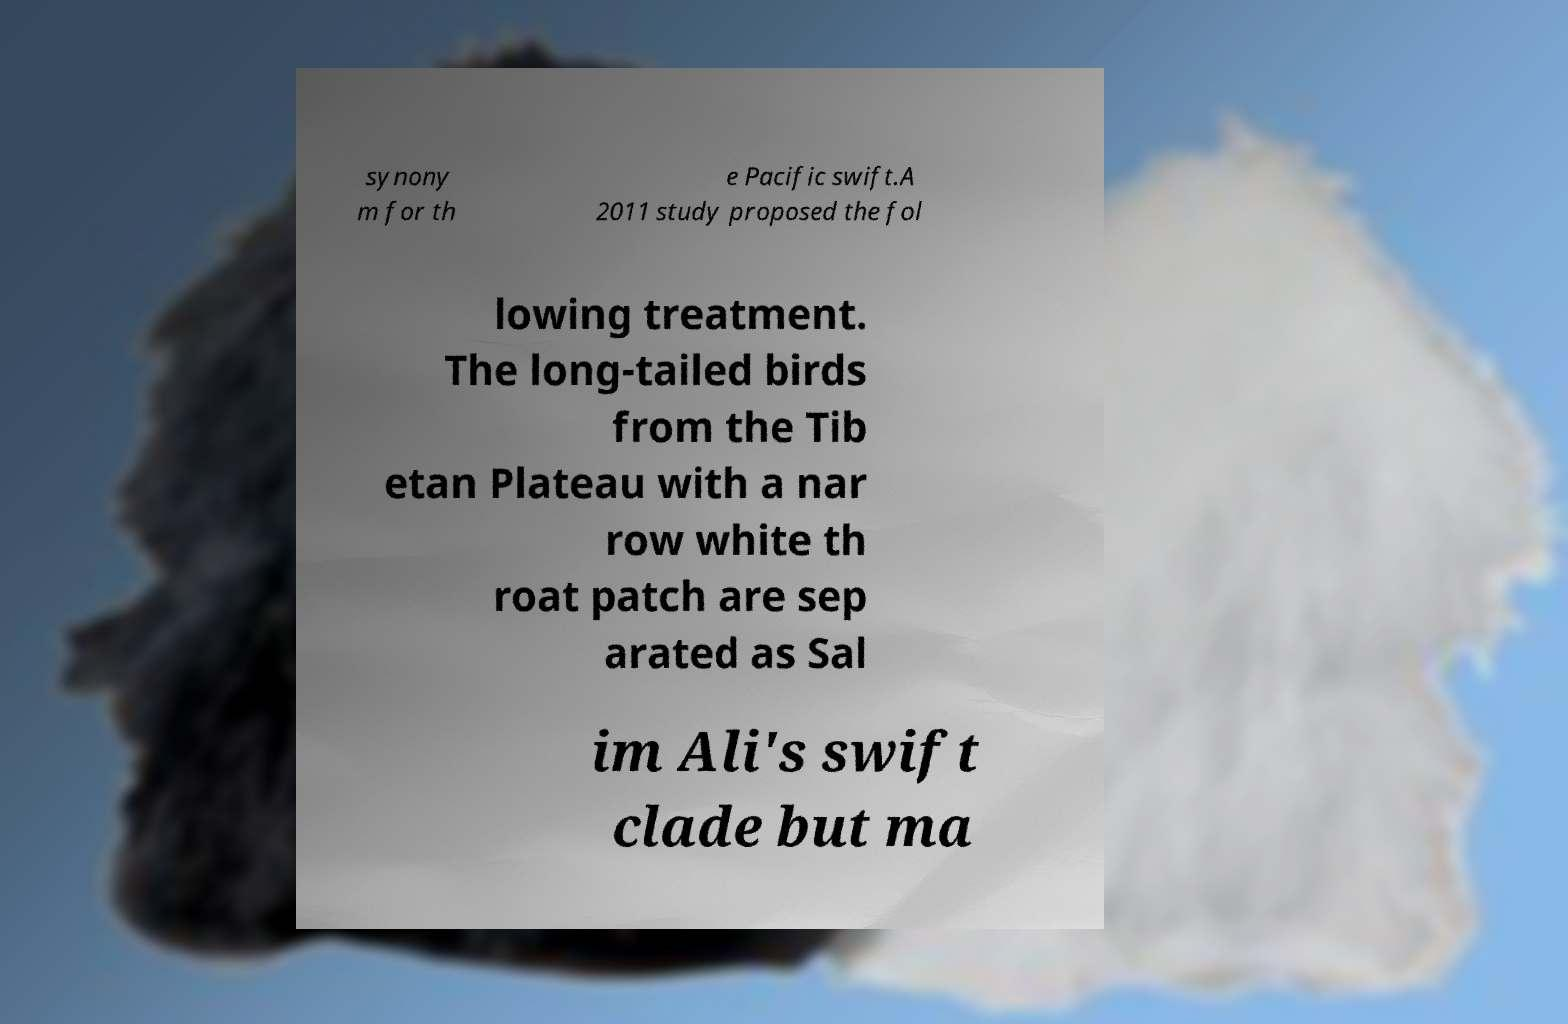What messages or text are displayed in this image? I need them in a readable, typed format. synony m for th e Pacific swift.A 2011 study proposed the fol lowing treatment. The long-tailed birds from the Tib etan Plateau with a nar row white th roat patch are sep arated as Sal im Ali's swift clade but ma 